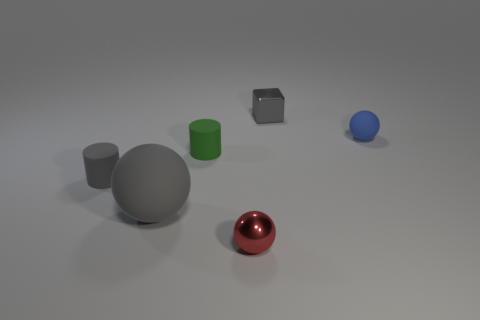Subtract all gray matte balls. How many balls are left? 2 Subtract 3 balls. How many balls are left? 0 Subtract all red balls. How many balls are left? 2 Add 3 tiny red shiny balls. How many objects exist? 9 Add 5 small spheres. How many small spheres are left? 7 Add 6 big objects. How many big objects exist? 7 Subtract 0 brown cubes. How many objects are left? 6 Subtract all blocks. How many objects are left? 5 Subtract all cyan cylinders. Subtract all cyan cubes. How many cylinders are left? 2 Subtract all purple blocks. How many gray cylinders are left? 1 